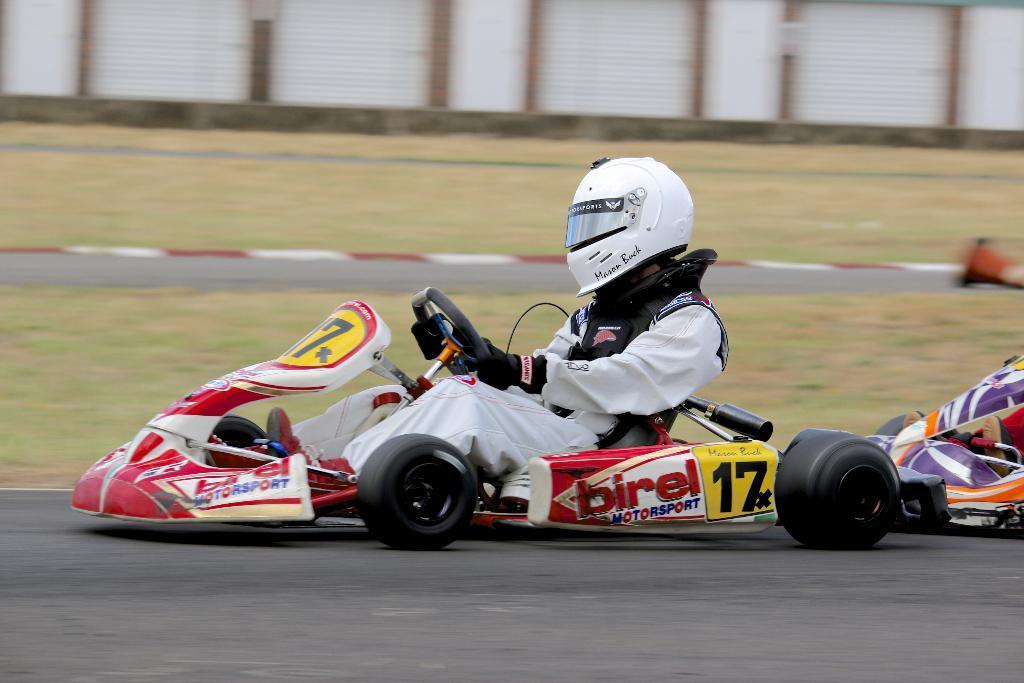In one or two sentences, can you explain what this image depicts? In foreground of the picture there are go-karts and a person driving. In the center of the picture there is grass and track. In the background it is blurred. In the background there is a wall. 